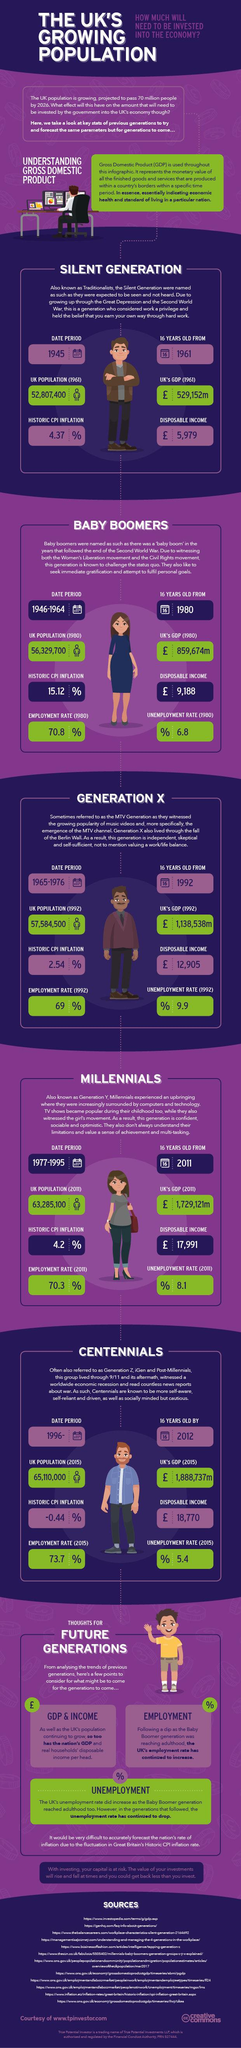Specify some key components in this picture. During the growing up of baby boomers, the Women's Liberation movement and the Civil Rights movement were the main events that shaped their upbringing. In 1980, the population of the United Kingdom was approximately 56,329,700. The calendar contains the written date of 1961, with the number 16 written beside it. The growing up of the silent generation was marked by two significant events: the Great Depression and the Second World War. The disposable income of Generation X in pounds is 12,905. 